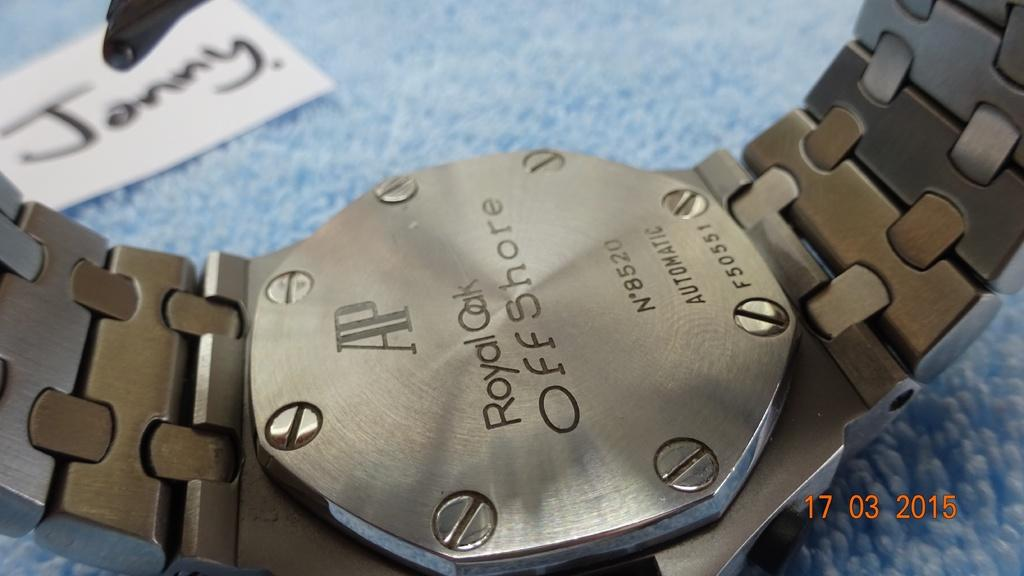<image>
Write a terse but informative summary of the picture. A watch is engraved with the text Royal Oak Offshore. 